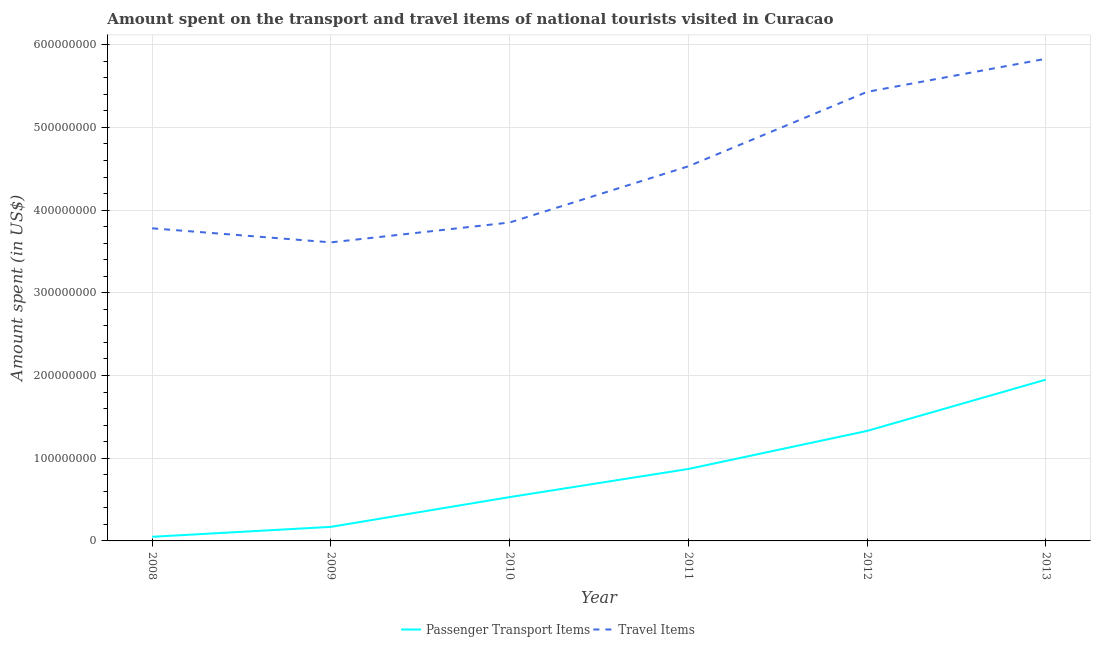How many different coloured lines are there?
Give a very brief answer. 2. Does the line corresponding to amount spent on passenger transport items intersect with the line corresponding to amount spent in travel items?
Keep it short and to the point. No. Is the number of lines equal to the number of legend labels?
Your answer should be compact. Yes. What is the amount spent in travel items in 2008?
Your answer should be very brief. 3.78e+08. Across all years, what is the maximum amount spent in travel items?
Provide a succinct answer. 5.83e+08. Across all years, what is the minimum amount spent on passenger transport items?
Provide a short and direct response. 5.00e+06. In which year was the amount spent in travel items maximum?
Your answer should be compact. 2013. In which year was the amount spent on passenger transport items minimum?
Provide a succinct answer. 2008. What is the total amount spent in travel items in the graph?
Ensure brevity in your answer.  2.70e+09. What is the difference between the amount spent on passenger transport items in 2008 and that in 2011?
Keep it short and to the point. -8.20e+07. What is the difference between the amount spent on passenger transport items in 2013 and the amount spent in travel items in 2011?
Your answer should be compact. -2.58e+08. What is the average amount spent in travel items per year?
Provide a short and direct response. 4.50e+08. In the year 2010, what is the difference between the amount spent in travel items and amount spent on passenger transport items?
Offer a terse response. 3.32e+08. In how many years, is the amount spent in travel items greater than 60000000 US$?
Ensure brevity in your answer.  6. What is the ratio of the amount spent on passenger transport items in 2008 to that in 2010?
Keep it short and to the point. 0.09. Is the difference between the amount spent on passenger transport items in 2009 and 2010 greater than the difference between the amount spent in travel items in 2009 and 2010?
Make the answer very short. No. What is the difference between the highest and the second highest amount spent in travel items?
Your response must be concise. 4.00e+07. What is the difference between the highest and the lowest amount spent in travel items?
Provide a short and direct response. 2.22e+08. In how many years, is the amount spent in travel items greater than the average amount spent in travel items taken over all years?
Offer a very short reply. 3. Is the amount spent in travel items strictly greater than the amount spent on passenger transport items over the years?
Provide a succinct answer. Yes. Is the amount spent in travel items strictly less than the amount spent on passenger transport items over the years?
Provide a short and direct response. No. How many years are there in the graph?
Your response must be concise. 6. Does the graph contain grids?
Provide a short and direct response. Yes. Where does the legend appear in the graph?
Keep it short and to the point. Bottom center. How many legend labels are there?
Make the answer very short. 2. How are the legend labels stacked?
Offer a terse response. Horizontal. What is the title of the graph?
Offer a terse response. Amount spent on the transport and travel items of national tourists visited in Curacao. Does "Commercial bank branches" appear as one of the legend labels in the graph?
Your response must be concise. No. What is the label or title of the X-axis?
Keep it short and to the point. Year. What is the label or title of the Y-axis?
Keep it short and to the point. Amount spent (in US$). What is the Amount spent (in US$) of Travel Items in 2008?
Provide a short and direct response. 3.78e+08. What is the Amount spent (in US$) in Passenger Transport Items in 2009?
Provide a short and direct response. 1.70e+07. What is the Amount spent (in US$) in Travel Items in 2009?
Give a very brief answer. 3.61e+08. What is the Amount spent (in US$) of Passenger Transport Items in 2010?
Your answer should be compact. 5.30e+07. What is the Amount spent (in US$) in Travel Items in 2010?
Make the answer very short. 3.85e+08. What is the Amount spent (in US$) in Passenger Transport Items in 2011?
Offer a terse response. 8.70e+07. What is the Amount spent (in US$) of Travel Items in 2011?
Offer a very short reply. 4.53e+08. What is the Amount spent (in US$) of Passenger Transport Items in 2012?
Provide a succinct answer. 1.33e+08. What is the Amount spent (in US$) in Travel Items in 2012?
Your answer should be compact. 5.43e+08. What is the Amount spent (in US$) of Passenger Transport Items in 2013?
Provide a short and direct response. 1.95e+08. What is the Amount spent (in US$) of Travel Items in 2013?
Offer a very short reply. 5.83e+08. Across all years, what is the maximum Amount spent (in US$) of Passenger Transport Items?
Offer a terse response. 1.95e+08. Across all years, what is the maximum Amount spent (in US$) in Travel Items?
Your answer should be very brief. 5.83e+08. Across all years, what is the minimum Amount spent (in US$) in Travel Items?
Your answer should be compact. 3.61e+08. What is the total Amount spent (in US$) of Passenger Transport Items in the graph?
Ensure brevity in your answer.  4.90e+08. What is the total Amount spent (in US$) in Travel Items in the graph?
Ensure brevity in your answer.  2.70e+09. What is the difference between the Amount spent (in US$) in Passenger Transport Items in 2008 and that in 2009?
Your answer should be compact. -1.20e+07. What is the difference between the Amount spent (in US$) in Travel Items in 2008 and that in 2009?
Your answer should be compact. 1.70e+07. What is the difference between the Amount spent (in US$) in Passenger Transport Items in 2008 and that in 2010?
Offer a very short reply. -4.80e+07. What is the difference between the Amount spent (in US$) in Travel Items in 2008 and that in 2010?
Ensure brevity in your answer.  -7.00e+06. What is the difference between the Amount spent (in US$) of Passenger Transport Items in 2008 and that in 2011?
Keep it short and to the point. -8.20e+07. What is the difference between the Amount spent (in US$) of Travel Items in 2008 and that in 2011?
Offer a terse response. -7.50e+07. What is the difference between the Amount spent (in US$) of Passenger Transport Items in 2008 and that in 2012?
Your answer should be compact. -1.28e+08. What is the difference between the Amount spent (in US$) of Travel Items in 2008 and that in 2012?
Your response must be concise. -1.65e+08. What is the difference between the Amount spent (in US$) of Passenger Transport Items in 2008 and that in 2013?
Make the answer very short. -1.90e+08. What is the difference between the Amount spent (in US$) of Travel Items in 2008 and that in 2013?
Make the answer very short. -2.05e+08. What is the difference between the Amount spent (in US$) in Passenger Transport Items in 2009 and that in 2010?
Make the answer very short. -3.60e+07. What is the difference between the Amount spent (in US$) in Travel Items in 2009 and that in 2010?
Keep it short and to the point. -2.40e+07. What is the difference between the Amount spent (in US$) of Passenger Transport Items in 2009 and that in 2011?
Provide a succinct answer. -7.00e+07. What is the difference between the Amount spent (in US$) of Travel Items in 2009 and that in 2011?
Your response must be concise. -9.20e+07. What is the difference between the Amount spent (in US$) of Passenger Transport Items in 2009 and that in 2012?
Your answer should be very brief. -1.16e+08. What is the difference between the Amount spent (in US$) of Travel Items in 2009 and that in 2012?
Ensure brevity in your answer.  -1.82e+08. What is the difference between the Amount spent (in US$) of Passenger Transport Items in 2009 and that in 2013?
Your answer should be very brief. -1.78e+08. What is the difference between the Amount spent (in US$) of Travel Items in 2009 and that in 2013?
Your response must be concise. -2.22e+08. What is the difference between the Amount spent (in US$) in Passenger Transport Items in 2010 and that in 2011?
Your answer should be compact. -3.40e+07. What is the difference between the Amount spent (in US$) of Travel Items in 2010 and that in 2011?
Offer a very short reply. -6.80e+07. What is the difference between the Amount spent (in US$) in Passenger Transport Items in 2010 and that in 2012?
Your response must be concise. -8.00e+07. What is the difference between the Amount spent (in US$) in Travel Items in 2010 and that in 2012?
Provide a short and direct response. -1.58e+08. What is the difference between the Amount spent (in US$) of Passenger Transport Items in 2010 and that in 2013?
Make the answer very short. -1.42e+08. What is the difference between the Amount spent (in US$) in Travel Items in 2010 and that in 2013?
Give a very brief answer. -1.98e+08. What is the difference between the Amount spent (in US$) in Passenger Transport Items in 2011 and that in 2012?
Ensure brevity in your answer.  -4.60e+07. What is the difference between the Amount spent (in US$) in Travel Items in 2011 and that in 2012?
Ensure brevity in your answer.  -9.00e+07. What is the difference between the Amount spent (in US$) of Passenger Transport Items in 2011 and that in 2013?
Make the answer very short. -1.08e+08. What is the difference between the Amount spent (in US$) in Travel Items in 2011 and that in 2013?
Your answer should be compact. -1.30e+08. What is the difference between the Amount spent (in US$) of Passenger Transport Items in 2012 and that in 2013?
Give a very brief answer. -6.20e+07. What is the difference between the Amount spent (in US$) in Travel Items in 2012 and that in 2013?
Give a very brief answer. -4.00e+07. What is the difference between the Amount spent (in US$) of Passenger Transport Items in 2008 and the Amount spent (in US$) of Travel Items in 2009?
Your answer should be very brief. -3.56e+08. What is the difference between the Amount spent (in US$) in Passenger Transport Items in 2008 and the Amount spent (in US$) in Travel Items in 2010?
Provide a short and direct response. -3.80e+08. What is the difference between the Amount spent (in US$) in Passenger Transport Items in 2008 and the Amount spent (in US$) in Travel Items in 2011?
Ensure brevity in your answer.  -4.48e+08. What is the difference between the Amount spent (in US$) in Passenger Transport Items in 2008 and the Amount spent (in US$) in Travel Items in 2012?
Give a very brief answer. -5.38e+08. What is the difference between the Amount spent (in US$) in Passenger Transport Items in 2008 and the Amount spent (in US$) in Travel Items in 2013?
Your response must be concise. -5.78e+08. What is the difference between the Amount spent (in US$) in Passenger Transport Items in 2009 and the Amount spent (in US$) in Travel Items in 2010?
Offer a very short reply. -3.68e+08. What is the difference between the Amount spent (in US$) of Passenger Transport Items in 2009 and the Amount spent (in US$) of Travel Items in 2011?
Make the answer very short. -4.36e+08. What is the difference between the Amount spent (in US$) in Passenger Transport Items in 2009 and the Amount spent (in US$) in Travel Items in 2012?
Keep it short and to the point. -5.26e+08. What is the difference between the Amount spent (in US$) of Passenger Transport Items in 2009 and the Amount spent (in US$) of Travel Items in 2013?
Offer a very short reply. -5.66e+08. What is the difference between the Amount spent (in US$) of Passenger Transport Items in 2010 and the Amount spent (in US$) of Travel Items in 2011?
Provide a succinct answer. -4.00e+08. What is the difference between the Amount spent (in US$) of Passenger Transport Items in 2010 and the Amount spent (in US$) of Travel Items in 2012?
Your answer should be compact. -4.90e+08. What is the difference between the Amount spent (in US$) in Passenger Transport Items in 2010 and the Amount spent (in US$) in Travel Items in 2013?
Keep it short and to the point. -5.30e+08. What is the difference between the Amount spent (in US$) in Passenger Transport Items in 2011 and the Amount spent (in US$) in Travel Items in 2012?
Provide a short and direct response. -4.56e+08. What is the difference between the Amount spent (in US$) in Passenger Transport Items in 2011 and the Amount spent (in US$) in Travel Items in 2013?
Keep it short and to the point. -4.96e+08. What is the difference between the Amount spent (in US$) of Passenger Transport Items in 2012 and the Amount spent (in US$) of Travel Items in 2013?
Your answer should be very brief. -4.50e+08. What is the average Amount spent (in US$) of Passenger Transport Items per year?
Your answer should be very brief. 8.17e+07. What is the average Amount spent (in US$) in Travel Items per year?
Offer a very short reply. 4.50e+08. In the year 2008, what is the difference between the Amount spent (in US$) in Passenger Transport Items and Amount spent (in US$) in Travel Items?
Offer a terse response. -3.73e+08. In the year 2009, what is the difference between the Amount spent (in US$) of Passenger Transport Items and Amount spent (in US$) of Travel Items?
Offer a terse response. -3.44e+08. In the year 2010, what is the difference between the Amount spent (in US$) in Passenger Transport Items and Amount spent (in US$) in Travel Items?
Provide a short and direct response. -3.32e+08. In the year 2011, what is the difference between the Amount spent (in US$) in Passenger Transport Items and Amount spent (in US$) in Travel Items?
Make the answer very short. -3.66e+08. In the year 2012, what is the difference between the Amount spent (in US$) in Passenger Transport Items and Amount spent (in US$) in Travel Items?
Your answer should be compact. -4.10e+08. In the year 2013, what is the difference between the Amount spent (in US$) of Passenger Transport Items and Amount spent (in US$) of Travel Items?
Offer a very short reply. -3.88e+08. What is the ratio of the Amount spent (in US$) in Passenger Transport Items in 2008 to that in 2009?
Provide a short and direct response. 0.29. What is the ratio of the Amount spent (in US$) in Travel Items in 2008 to that in 2009?
Your answer should be very brief. 1.05. What is the ratio of the Amount spent (in US$) of Passenger Transport Items in 2008 to that in 2010?
Give a very brief answer. 0.09. What is the ratio of the Amount spent (in US$) in Travel Items in 2008 to that in 2010?
Your answer should be very brief. 0.98. What is the ratio of the Amount spent (in US$) in Passenger Transport Items in 2008 to that in 2011?
Keep it short and to the point. 0.06. What is the ratio of the Amount spent (in US$) of Travel Items in 2008 to that in 2011?
Make the answer very short. 0.83. What is the ratio of the Amount spent (in US$) of Passenger Transport Items in 2008 to that in 2012?
Offer a terse response. 0.04. What is the ratio of the Amount spent (in US$) in Travel Items in 2008 to that in 2012?
Your answer should be compact. 0.7. What is the ratio of the Amount spent (in US$) of Passenger Transport Items in 2008 to that in 2013?
Your answer should be very brief. 0.03. What is the ratio of the Amount spent (in US$) in Travel Items in 2008 to that in 2013?
Provide a short and direct response. 0.65. What is the ratio of the Amount spent (in US$) in Passenger Transport Items in 2009 to that in 2010?
Provide a short and direct response. 0.32. What is the ratio of the Amount spent (in US$) in Travel Items in 2009 to that in 2010?
Ensure brevity in your answer.  0.94. What is the ratio of the Amount spent (in US$) in Passenger Transport Items in 2009 to that in 2011?
Your answer should be compact. 0.2. What is the ratio of the Amount spent (in US$) in Travel Items in 2009 to that in 2011?
Give a very brief answer. 0.8. What is the ratio of the Amount spent (in US$) in Passenger Transport Items in 2009 to that in 2012?
Make the answer very short. 0.13. What is the ratio of the Amount spent (in US$) of Travel Items in 2009 to that in 2012?
Provide a succinct answer. 0.66. What is the ratio of the Amount spent (in US$) in Passenger Transport Items in 2009 to that in 2013?
Provide a short and direct response. 0.09. What is the ratio of the Amount spent (in US$) of Travel Items in 2009 to that in 2013?
Your answer should be compact. 0.62. What is the ratio of the Amount spent (in US$) in Passenger Transport Items in 2010 to that in 2011?
Your response must be concise. 0.61. What is the ratio of the Amount spent (in US$) of Travel Items in 2010 to that in 2011?
Keep it short and to the point. 0.85. What is the ratio of the Amount spent (in US$) of Passenger Transport Items in 2010 to that in 2012?
Give a very brief answer. 0.4. What is the ratio of the Amount spent (in US$) in Travel Items in 2010 to that in 2012?
Provide a short and direct response. 0.71. What is the ratio of the Amount spent (in US$) of Passenger Transport Items in 2010 to that in 2013?
Give a very brief answer. 0.27. What is the ratio of the Amount spent (in US$) of Travel Items in 2010 to that in 2013?
Provide a short and direct response. 0.66. What is the ratio of the Amount spent (in US$) of Passenger Transport Items in 2011 to that in 2012?
Provide a short and direct response. 0.65. What is the ratio of the Amount spent (in US$) in Travel Items in 2011 to that in 2012?
Offer a very short reply. 0.83. What is the ratio of the Amount spent (in US$) in Passenger Transport Items in 2011 to that in 2013?
Provide a short and direct response. 0.45. What is the ratio of the Amount spent (in US$) of Travel Items in 2011 to that in 2013?
Keep it short and to the point. 0.78. What is the ratio of the Amount spent (in US$) in Passenger Transport Items in 2012 to that in 2013?
Provide a short and direct response. 0.68. What is the ratio of the Amount spent (in US$) of Travel Items in 2012 to that in 2013?
Keep it short and to the point. 0.93. What is the difference between the highest and the second highest Amount spent (in US$) of Passenger Transport Items?
Provide a short and direct response. 6.20e+07. What is the difference between the highest and the second highest Amount spent (in US$) in Travel Items?
Give a very brief answer. 4.00e+07. What is the difference between the highest and the lowest Amount spent (in US$) in Passenger Transport Items?
Provide a short and direct response. 1.90e+08. What is the difference between the highest and the lowest Amount spent (in US$) of Travel Items?
Make the answer very short. 2.22e+08. 